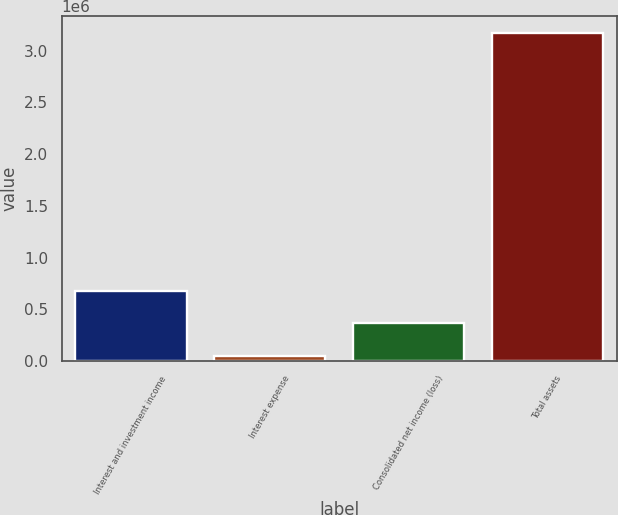<chart> <loc_0><loc_0><loc_500><loc_500><bar_chart><fcel>Interest and investment income<fcel>Interest expense<fcel>Consolidated net income (loss)<fcel>Total assets<nl><fcel>677333<fcel>53124<fcel>365229<fcel>3.17417e+06<nl></chart> 